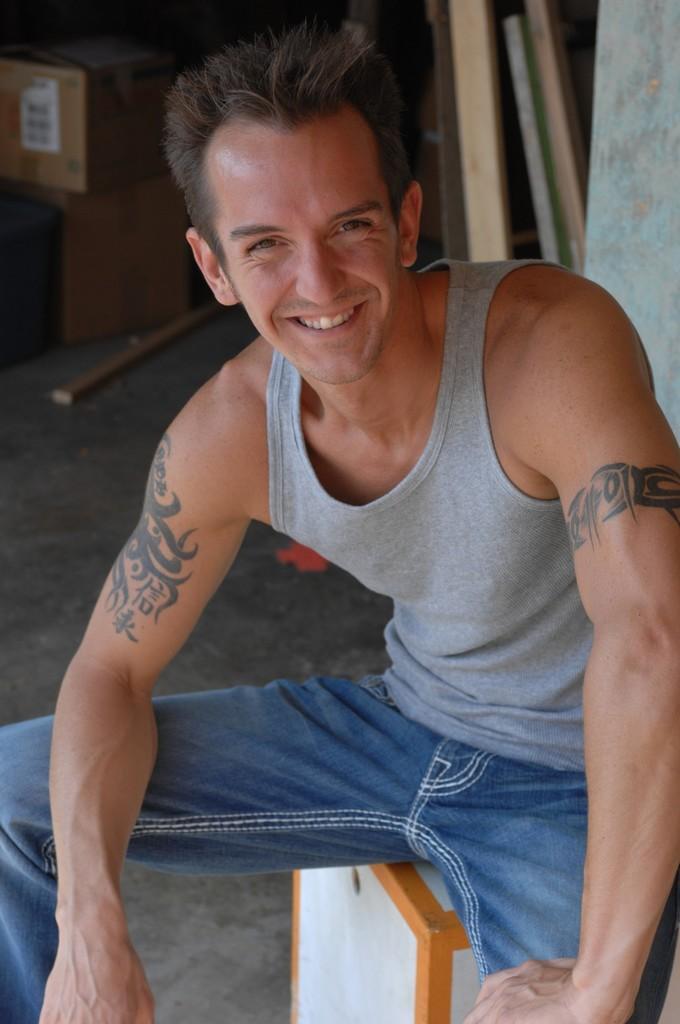Please provide a concise description of this image. In the image in the center we can see one man sitting on the stool and he is smiling,which we can see on his face. In the background there is a wall,wood,box and few other objects. 